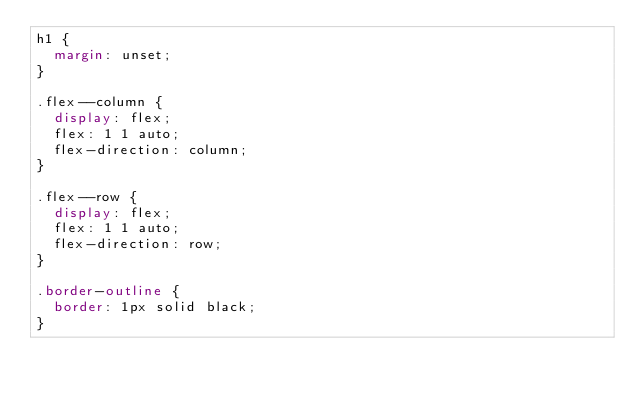<code> <loc_0><loc_0><loc_500><loc_500><_CSS_>h1 {
  margin: unset;
}

.flex--column {
  display: flex;
  flex: 1 1 auto;
  flex-direction: column;
}

.flex--row {
  display: flex;
  flex: 1 1 auto;
  flex-direction: row;
}

.border-outline {
  border: 1px solid black;
}
</code> 